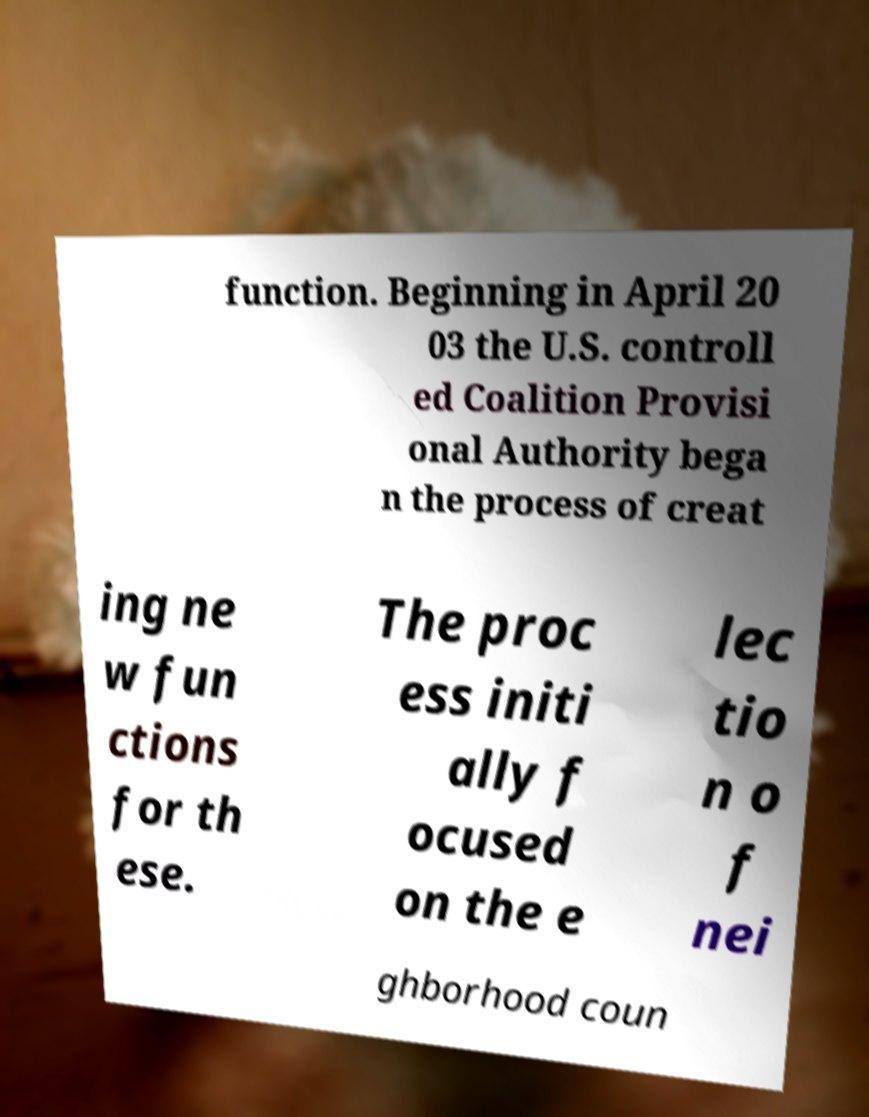For documentation purposes, I need the text within this image transcribed. Could you provide that? function. Beginning in April 20 03 the U.S. controll ed Coalition Provisi onal Authority bega n the process of creat ing ne w fun ctions for th ese. The proc ess initi ally f ocused on the e lec tio n o f nei ghborhood coun 